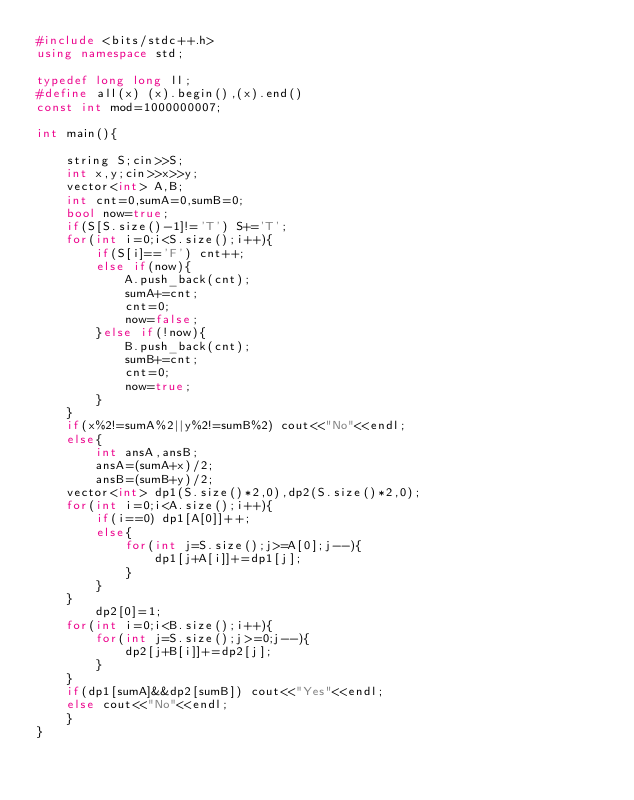Convert code to text. <code><loc_0><loc_0><loc_500><loc_500><_C++_>#include <bits/stdc++.h>
using namespace std;

typedef long long ll;
#define all(x) (x).begin(),(x).end()
const int mod=1000000007;

int main(){
    
    string S;cin>>S;
    int x,y;cin>>x>>y;
    vector<int> A,B;
    int cnt=0,sumA=0,sumB=0;
    bool now=true;
    if(S[S.size()-1]!='T') S+='T';
    for(int i=0;i<S.size();i++){
        if(S[i]=='F') cnt++;
        else if(now){
            A.push_back(cnt);
            sumA+=cnt;
            cnt=0;
            now=false;
        }else if(!now){
            B.push_back(cnt);
            sumB+=cnt;
            cnt=0;
            now=true;
        }
    }
    if(x%2!=sumA%2||y%2!=sumB%2) cout<<"No"<<endl;
    else{
        int ansA,ansB;
        ansA=(sumA+x)/2;
        ansB=(sumB+y)/2;
    vector<int> dp1(S.size()*2,0),dp2(S.size()*2,0);
    for(int i=0;i<A.size();i++){
        if(i==0) dp1[A[0]]++;
        else{
            for(int j=S.size();j>=A[0];j--){
                dp1[j+A[i]]+=dp1[j];
            }
        }
    }
        dp2[0]=1;
    for(int i=0;i<B.size();i++){
        for(int j=S.size();j>=0;j--){
            dp2[j+B[i]]+=dp2[j];
        }
    }
    if(dp1[sumA]&&dp2[sumB]) cout<<"Yes"<<endl;
    else cout<<"No"<<endl;
    }
}
</code> 